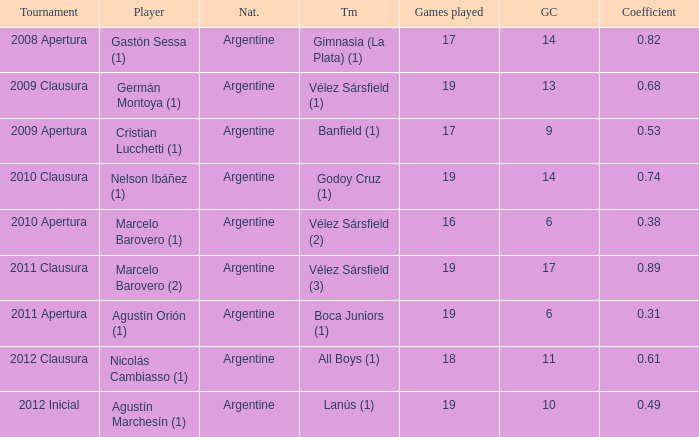What is the coefficient for agustín marchesín (1)? 0.49. 